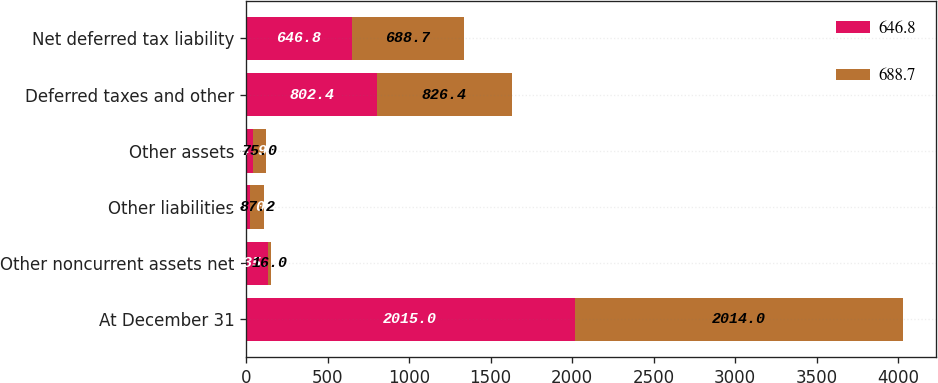<chart> <loc_0><loc_0><loc_500><loc_500><stacked_bar_chart><ecel><fcel>At December 31<fcel>Other noncurrent assets net<fcel>Other liabilities<fcel>Other assets<fcel>Deferred taxes and other<fcel>Net deferred tax liability<nl><fcel>646.8<fcel>2015<fcel>135.7<fcel>25<fcel>44.9<fcel>802.4<fcel>646.8<nl><fcel>688.7<fcel>2014<fcel>16<fcel>87.2<fcel>75<fcel>826.4<fcel>688.7<nl></chart> 